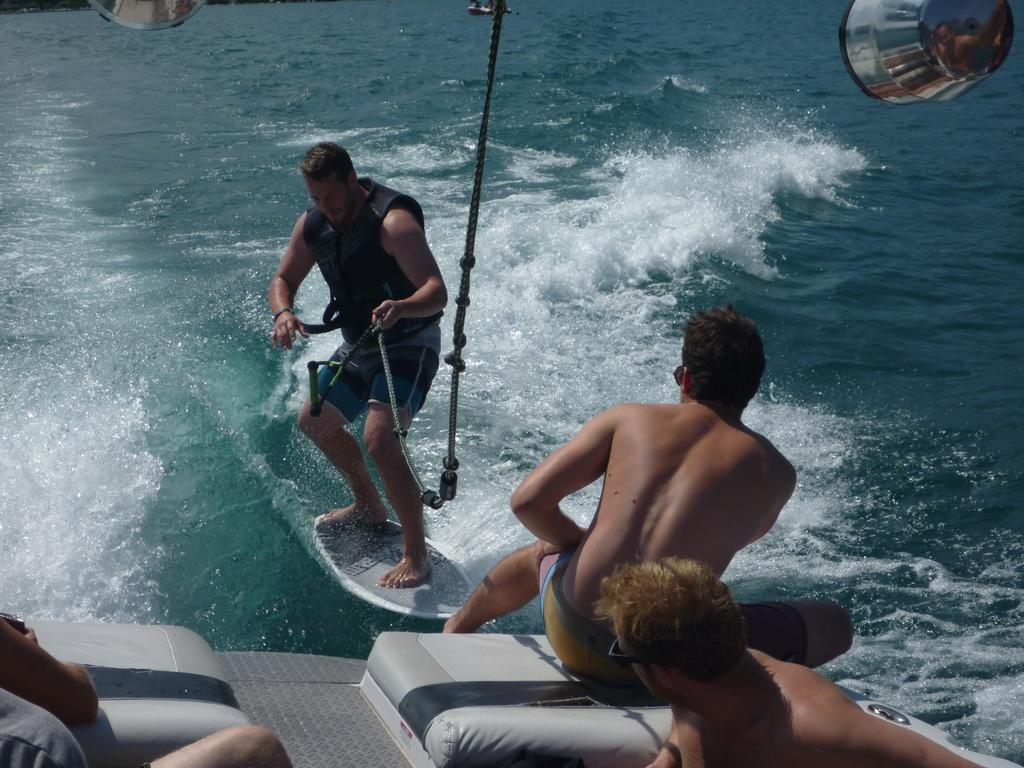What are the people in the image doing? The people in the image are sitting on a boat. What activity is one person engaged in besides sitting on the boat? One person is surfing on the water. What is the person surfing wearing? The person surfing is wearing a jacket. What other objects can be seen in the image? There are other objects visible in the image, but their specific details are not mentioned in the provided facts. What type of beast can be seen roaming the town in the image? There is no beast or town present in the image; it features people on a boat and a person surfing. 